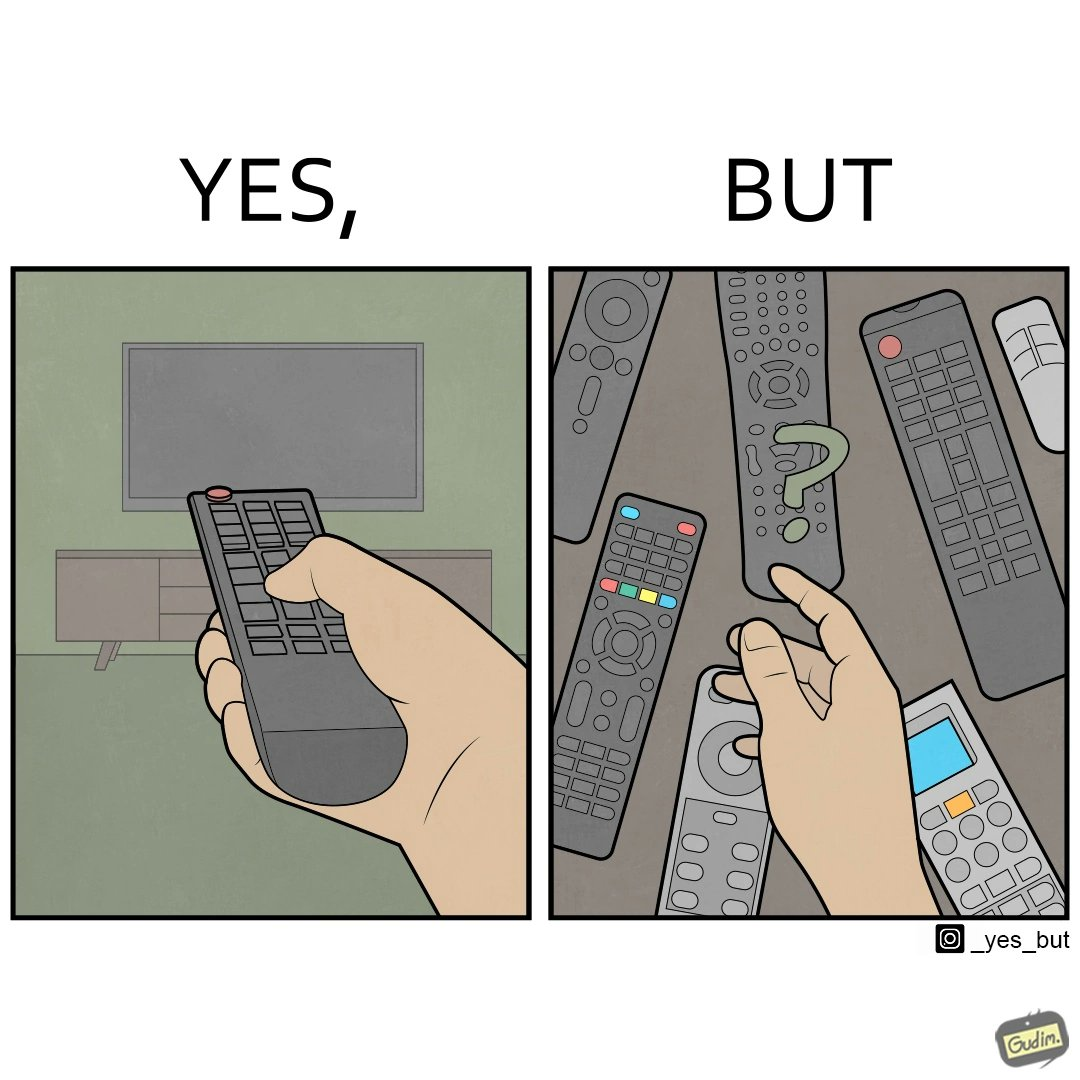Is this a satirical image? Yes, this image is satirical. 